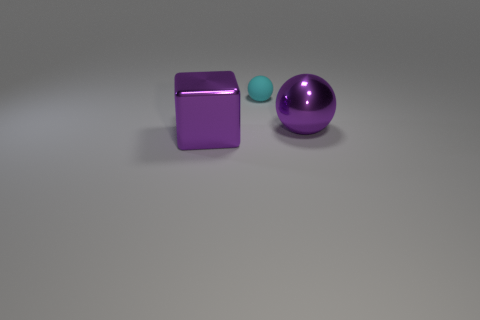Are the big purple sphere and the purple cube made of the same material?
Make the answer very short. Yes. Is there a large purple ball in front of the purple thing that is on the right side of the block?
Your answer should be compact. No. What number of balls are both behind the metallic ball and right of the tiny cyan rubber thing?
Ensure brevity in your answer.  0. What shape is the metallic object left of the purple sphere?
Offer a terse response. Cube. How many matte balls are the same size as the rubber thing?
Make the answer very short. 0. There is a shiny thing that is in front of the big purple metal sphere; is its color the same as the small matte sphere?
Make the answer very short. No. What is the material of the thing that is to the left of the large ball and behind the large block?
Offer a terse response. Rubber. Are there more small cyan balls than purple objects?
Ensure brevity in your answer.  No. What is the color of the large object to the left of the sphere that is behind the purple object that is behind the large block?
Your response must be concise. Purple. Does the purple object that is on the right side of the small cyan rubber sphere have the same material as the block?
Offer a terse response. Yes. 